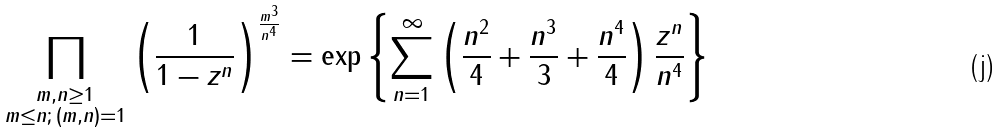Convert formula to latex. <formula><loc_0><loc_0><loc_500><loc_500>\prod _ { \substack { m , n \geq 1 \\ m \leq n ; \, ( m , n ) = 1 } } \left ( \frac { 1 } { 1 - z ^ { n } } \right ) ^ { \frac { m ^ { 3 } } { n ^ { 4 } } } = \exp \left \{ \sum _ { n = 1 } ^ { \infty } \left ( \frac { n ^ { 2 } } { 4 } + \frac { n ^ { 3 } } { 3 } + \frac { n ^ { 4 } } { 4 } \right ) \frac { z ^ { n } } { n ^ { 4 } } \right \}</formula> 